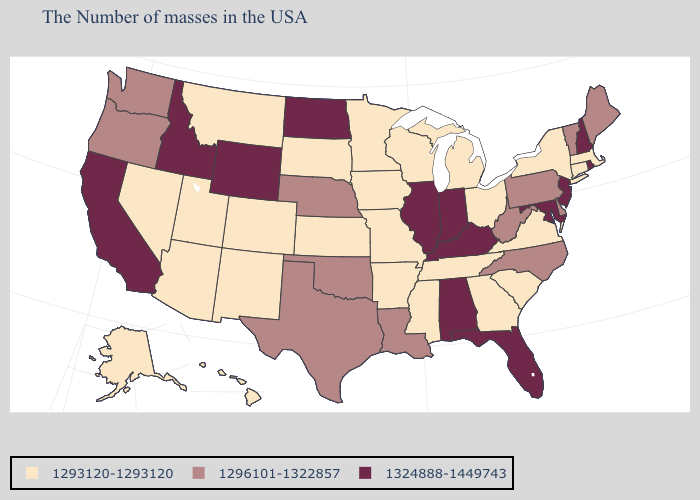Is the legend a continuous bar?
Concise answer only. No. Name the states that have a value in the range 1296101-1322857?
Short answer required. Maine, Vermont, Delaware, Pennsylvania, North Carolina, West Virginia, Louisiana, Nebraska, Oklahoma, Texas, Washington, Oregon. Name the states that have a value in the range 1293120-1293120?
Quick response, please. Massachusetts, Connecticut, New York, Virginia, South Carolina, Ohio, Georgia, Michigan, Tennessee, Wisconsin, Mississippi, Missouri, Arkansas, Minnesota, Iowa, Kansas, South Dakota, Colorado, New Mexico, Utah, Montana, Arizona, Nevada, Alaska, Hawaii. What is the value of Michigan?
Answer briefly. 1293120-1293120. What is the value of Hawaii?
Quick response, please. 1293120-1293120. What is the value of Nevada?
Write a very short answer. 1293120-1293120. How many symbols are there in the legend?
Quick response, please. 3. Name the states that have a value in the range 1296101-1322857?
Write a very short answer. Maine, Vermont, Delaware, Pennsylvania, North Carolina, West Virginia, Louisiana, Nebraska, Oklahoma, Texas, Washington, Oregon. Which states have the lowest value in the Northeast?
Answer briefly. Massachusetts, Connecticut, New York. Which states have the lowest value in the USA?
Be succinct. Massachusetts, Connecticut, New York, Virginia, South Carolina, Ohio, Georgia, Michigan, Tennessee, Wisconsin, Mississippi, Missouri, Arkansas, Minnesota, Iowa, Kansas, South Dakota, Colorado, New Mexico, Utah, Montana, Arizona, Nevada, Alaska, Hawaii. What is the value of New Hampshire?
Quick response, please. 1324888-1449743. Name the states that have a value in the range 1324888-1449743?
Short answer required. Rhode Island, New Hampshire, New Jersey, Maryland, Florida, Kentucky, Indiana, Alabama, Illinois, North Dakota, Wyoming, Idaho, California. Does South Dakota have the same value as Virginia?
Write a very short answer. Yes. Name the states that have a value in the range 1324888-1449743?
Be succinct. Rhode Island, New Hampshire, New Jersey, Maryland, Florida, Kentucky, Indiana, Alabama, Illinois, North Dakota, Wyoming, Idaho, California. Which states hav the highest value in the West?
Give a very brief answer. Wyoming, Idaho, California. 